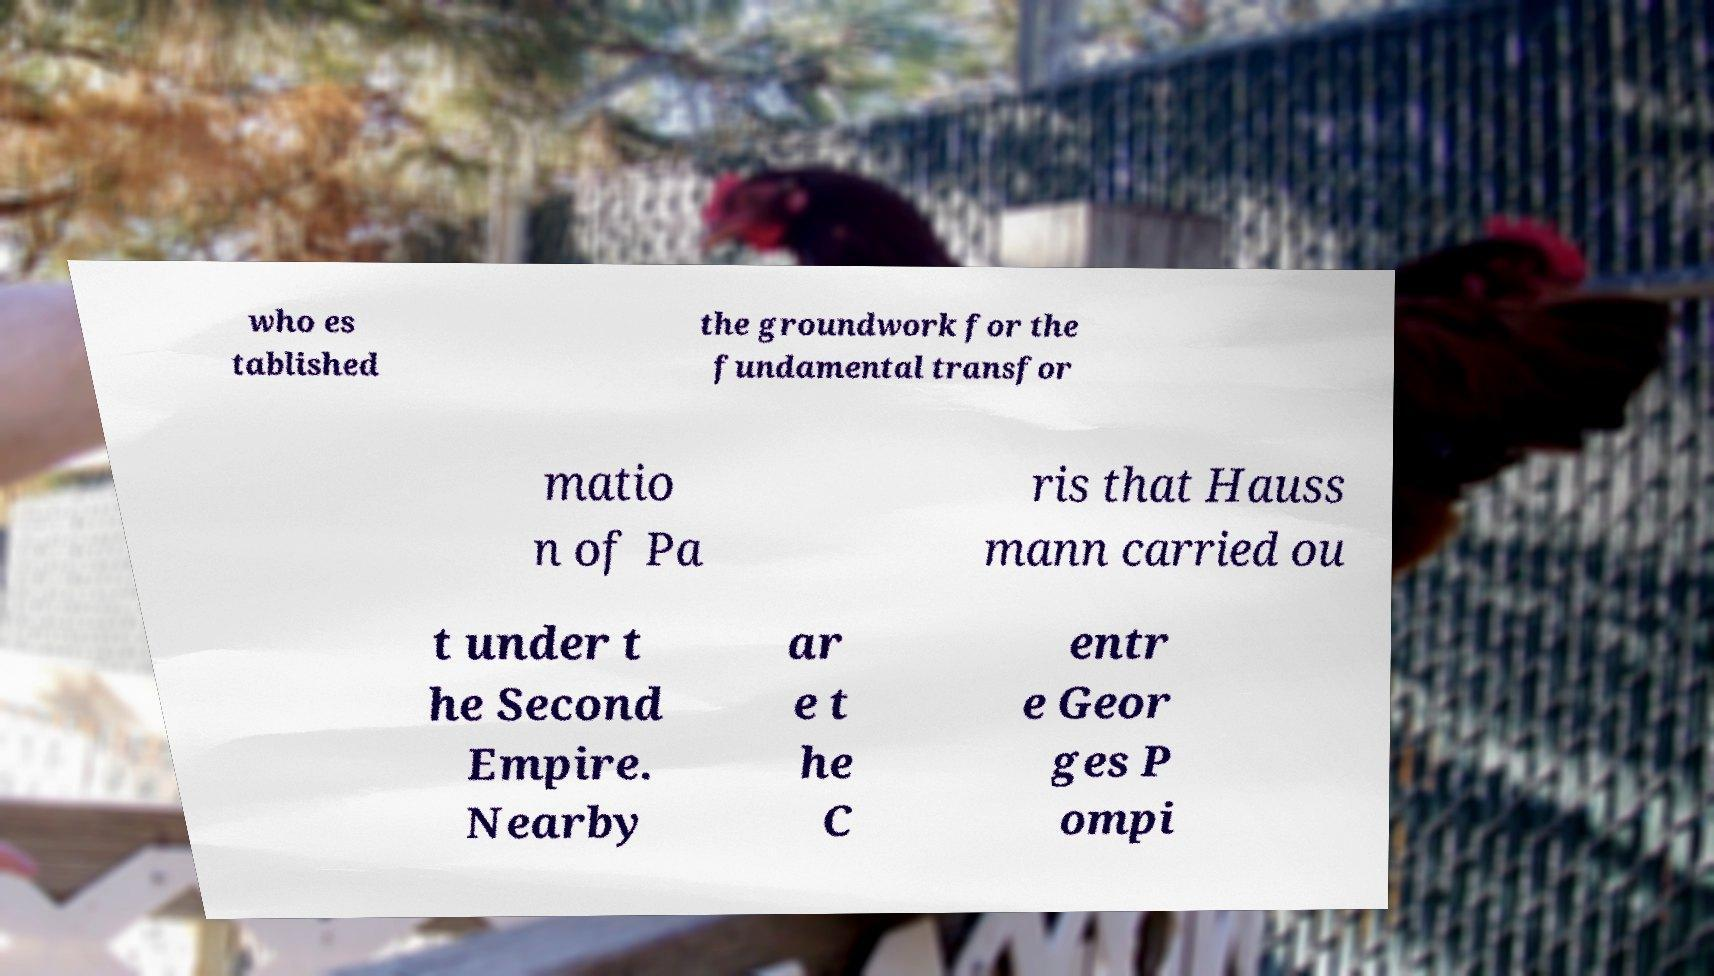Could you extract and type out the text from this image? who es tablished the groundwork for the fundamental transfor matio n of Pa ris that Hauss mann carried ou t under t he Second Empire. Nearby ar e t he C entr e Geor ges P ompi 